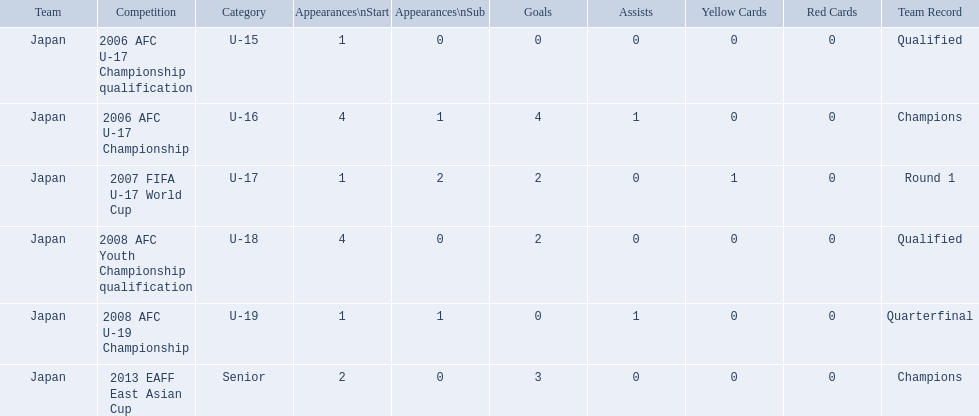What are all of the competitions? 2006 AFC U-17 Championship qualification, 2006 AFC U-17 Championship, 2007 FIFA U-17 World Cup, 2008 AFC Youth Championship qualification, 2008 AFC U-19 Championship, 2013 EAFF East Asian Cup. How many starting appearances were there? 1, 4, 1, 4, 1, 2. What about just during 2013 eaff east asian cup and 2007 fifa u-17 world cup? 1, 2. Which of those had more starting appearances? 2013 EAFF East Asian Cup. 